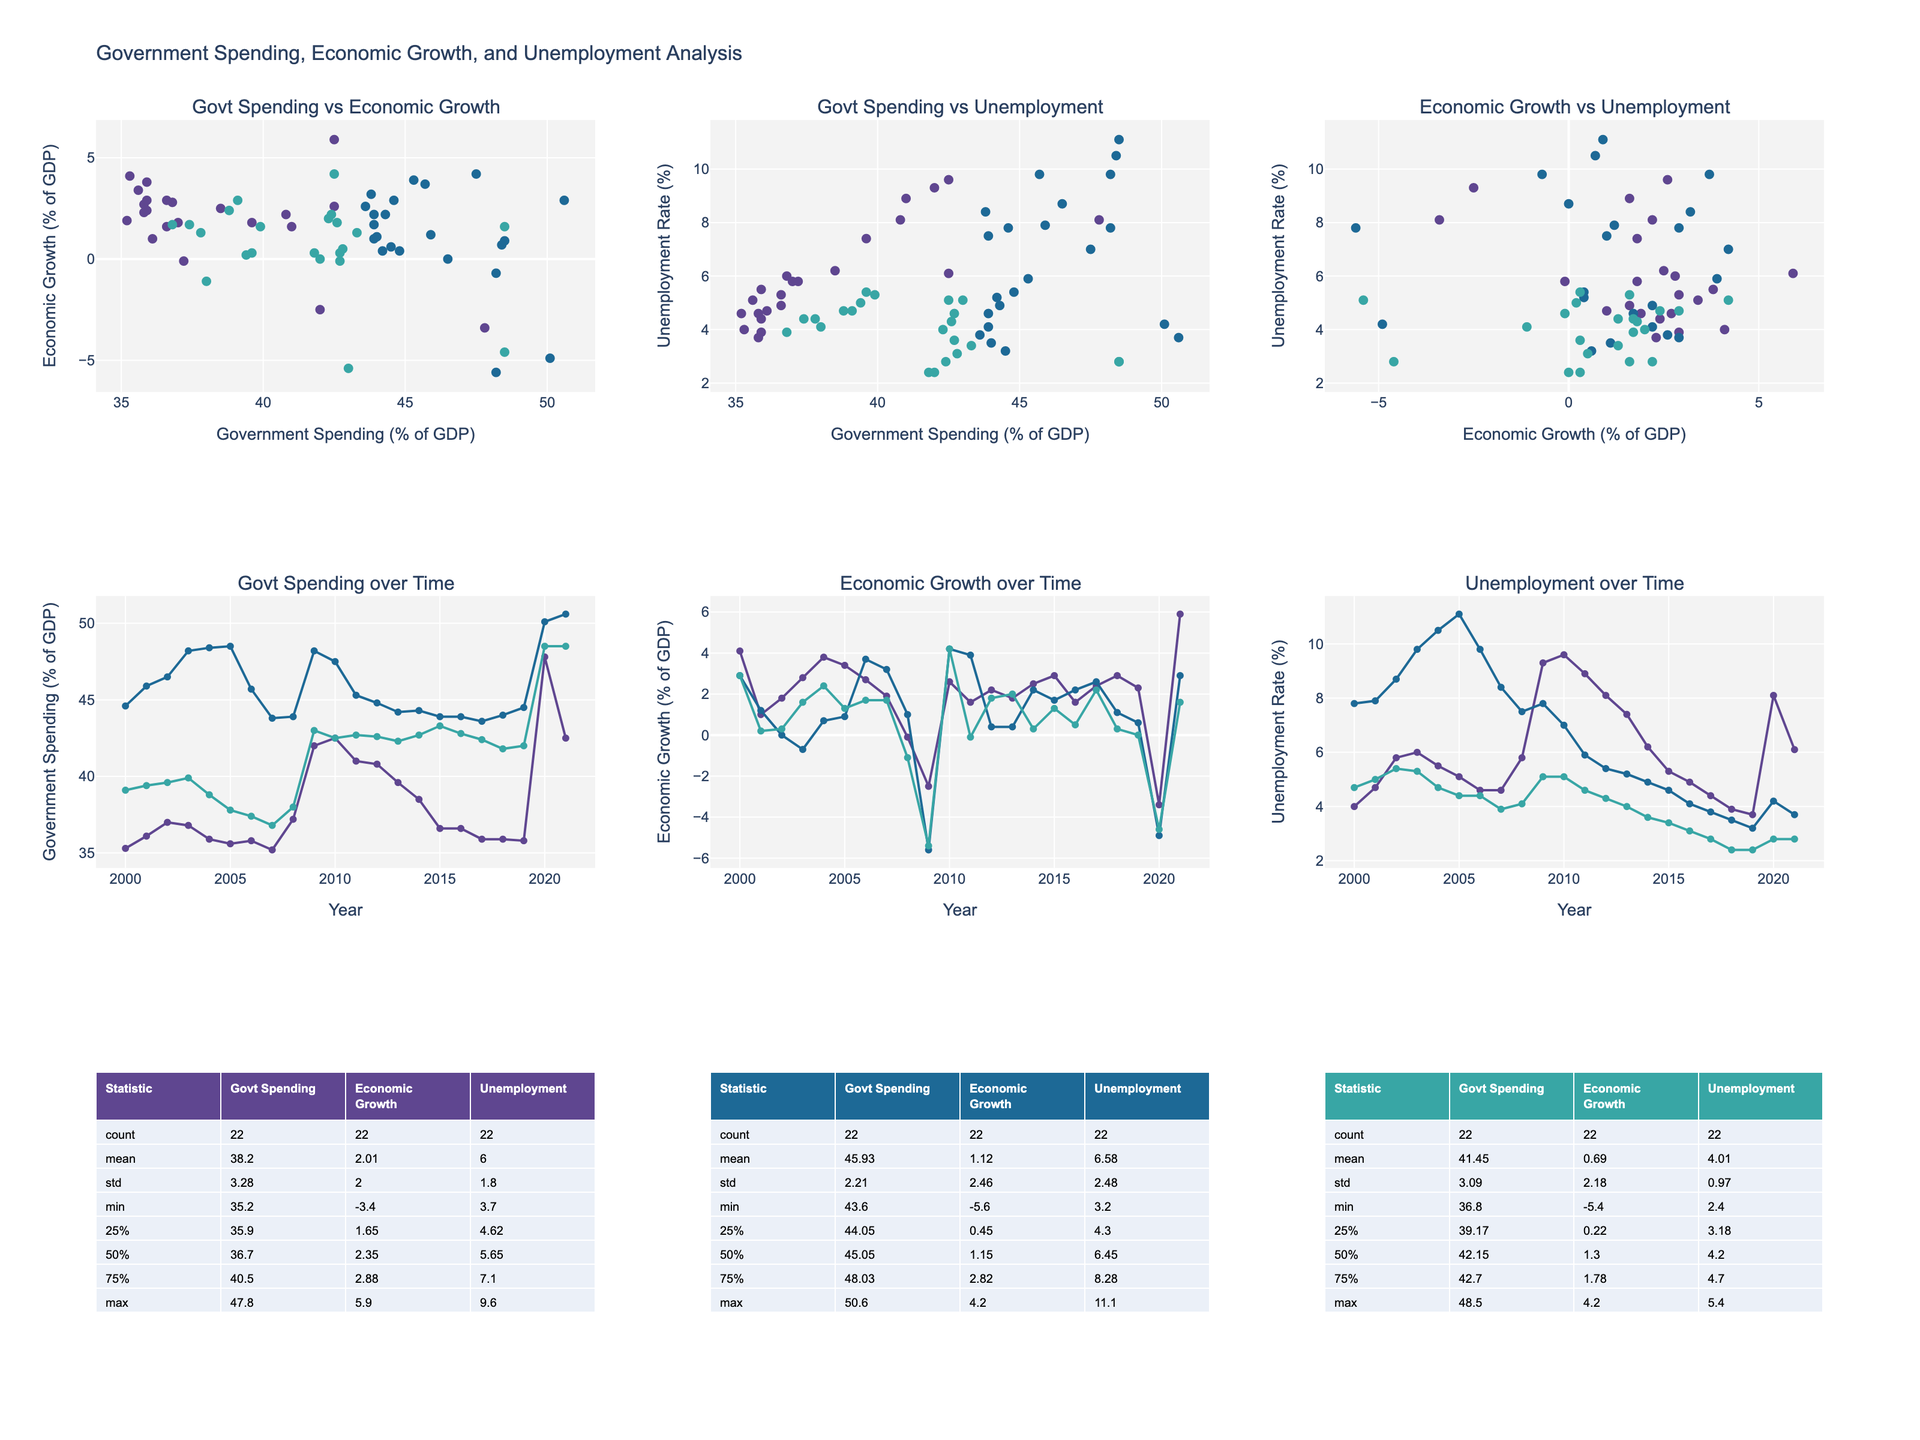What is the title of the plot? The title of the plot is usually placed at the top of the figure and is often the largest text. It provides an overview of what the figure represents. Here, it is "Government Spending, Economic Growth, and Unemployment Analysis."
Answer: Government Spending, Economic Growth, and Unemployment Analysis Which country has the highest government spending as a percentage of GDP in 2020? In the subplot titled "Govt Spending over Time," look for the data point in the year 2020. The highest value is colored according to the country. Observing the line traces, the highest point corresponds to the United States.
Answer: United States What is the trend of unemployment in Germany from 2000 to 2021? In the subplot "Unemployment over Time," locate the line trace for Germany and observe the change over the years from 2000 to 2021. The unemployment rate in Germany starts high around 10.5% and gradually decreases to around 3.7% with some fluctuations.
Answer: Decreasing trend Which country experienced the highest spike in unemployment rate during the Great Recession (2008-2009)? In the subplot "Unemployment over Time," focus on the period between 2008 and 2009. Compare the vertical jumps in unemployment rates across the countries. The United States shows the largest increase in unemployment during this period.
Answer: United States How does economic growth relate to government spending in Japan? In the subplot "Govt Spending vs Economic Growth," locate the points that represent Japan. Observe the spread and trend of these points. Generally, Japan's economic growth rate shows a modest positive correlation with government spending.
Answer: Modestly positive correlation What is the average unemployment rate in the United States from 2000 to 2021? In the summary table for the United States, find the row representing the average (mean) for the "Unemployment" column. This statistical summary directly provides the average unemployment rate.
Answer: Approximately 6.1% Which country had the highest economic growth in 2021? In the subplot "Economic Growth over Time," look for the data points in the year 2021. Compare the y-values (economic growth percentages) for each country. The country with the highest economic growth is the United States.
Answer: United States Comparing Germany and Japan, which country had a steadier government spending percentage from 2000 to 2021? In the subplot "Govt Spending over Time," observe the lines for Germany and Japan. Germany's line shows a more consistent trend compared to Japan, which has more fluctuations.
Answer: Germany Did the United States have positive economic growth every year from 2000 to 2021? In the subplot "Economic Growth over Time," trace the line for the United States. Identify the years where the line goes below 0%, indicating negative growth. The United States had negative growth in 2008, 2009, and 2020.
Answer: No What was the unemployment rate in Japan in the year 2003? In the subplot "Unemployment over Time," find the year 2003 on the x-axis for Japan, then trace up to the y-axis. The rate is approximately 5.3%.
Answer: 5.3% 